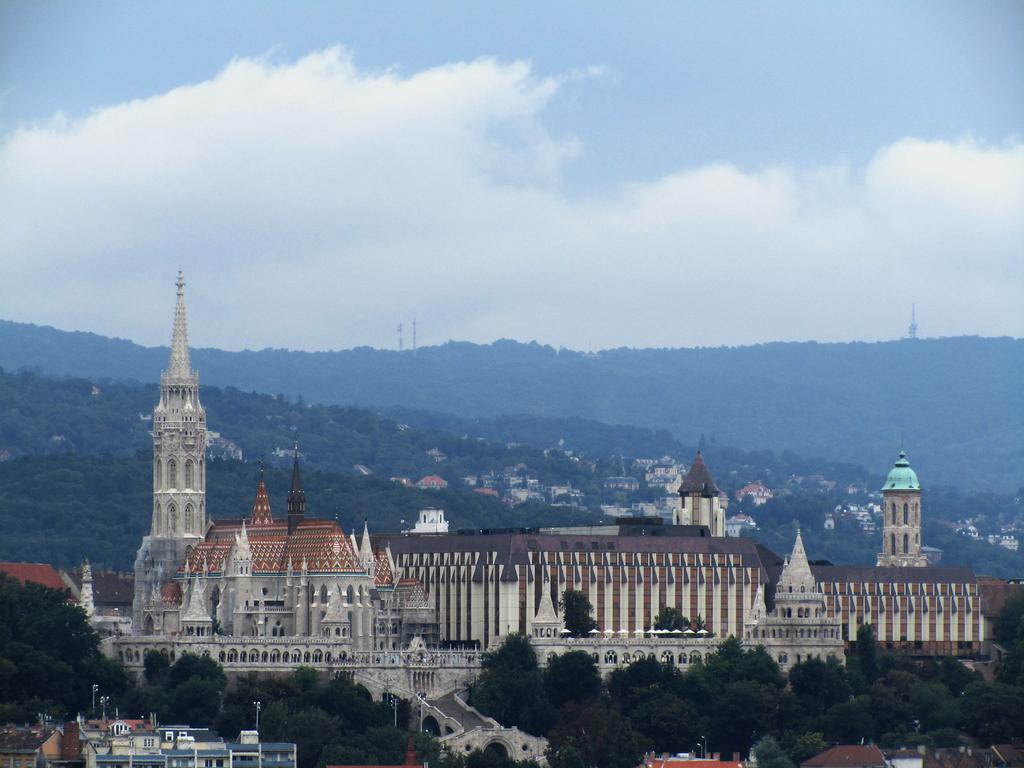What types of structures can be seen in the image? There are multiple buildings in the image. What other natural elements are present in the image? There are trees in the image. What can be seen in the background of the image? Clouds and the sky are visible in the background of the image. What type of jelly is being served at the meeting in the image? There is no meeting or jelly present in the image; it features multiple buildings, trees, clouds, and the sky. 